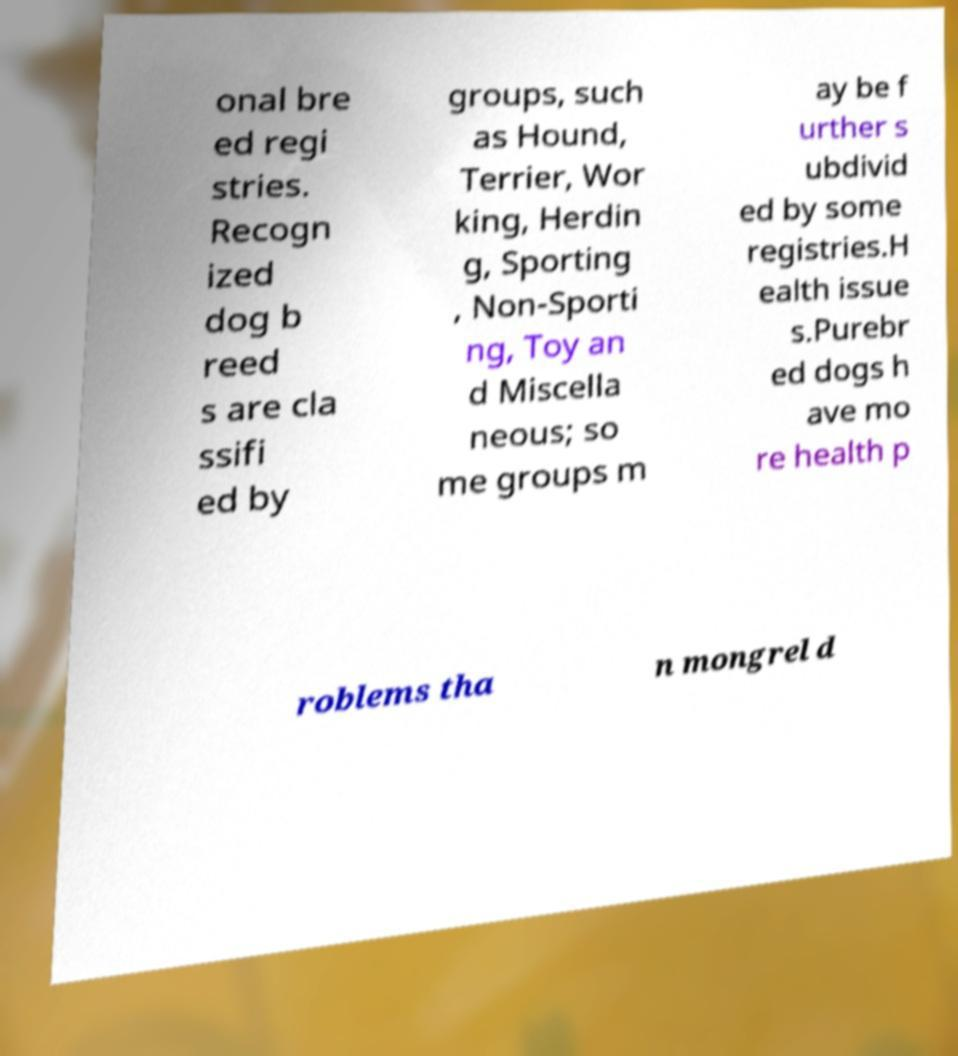Could you assist in decoding the text presented in this image and type it out clearly? onal bre ed regi stries. Recogn ized dog b reed s are cla ssifi ed by groups, such as Hound, Terrier, Wor king, Herdin g, Sporting , Non-Sporti ng, Toy an d Miscella neous; so me groups m ay be f urther s ubdivid ed by some registries.H ealth issue s.Purebr ed dogs h ave mo re health p roblems tha n mongrel d 